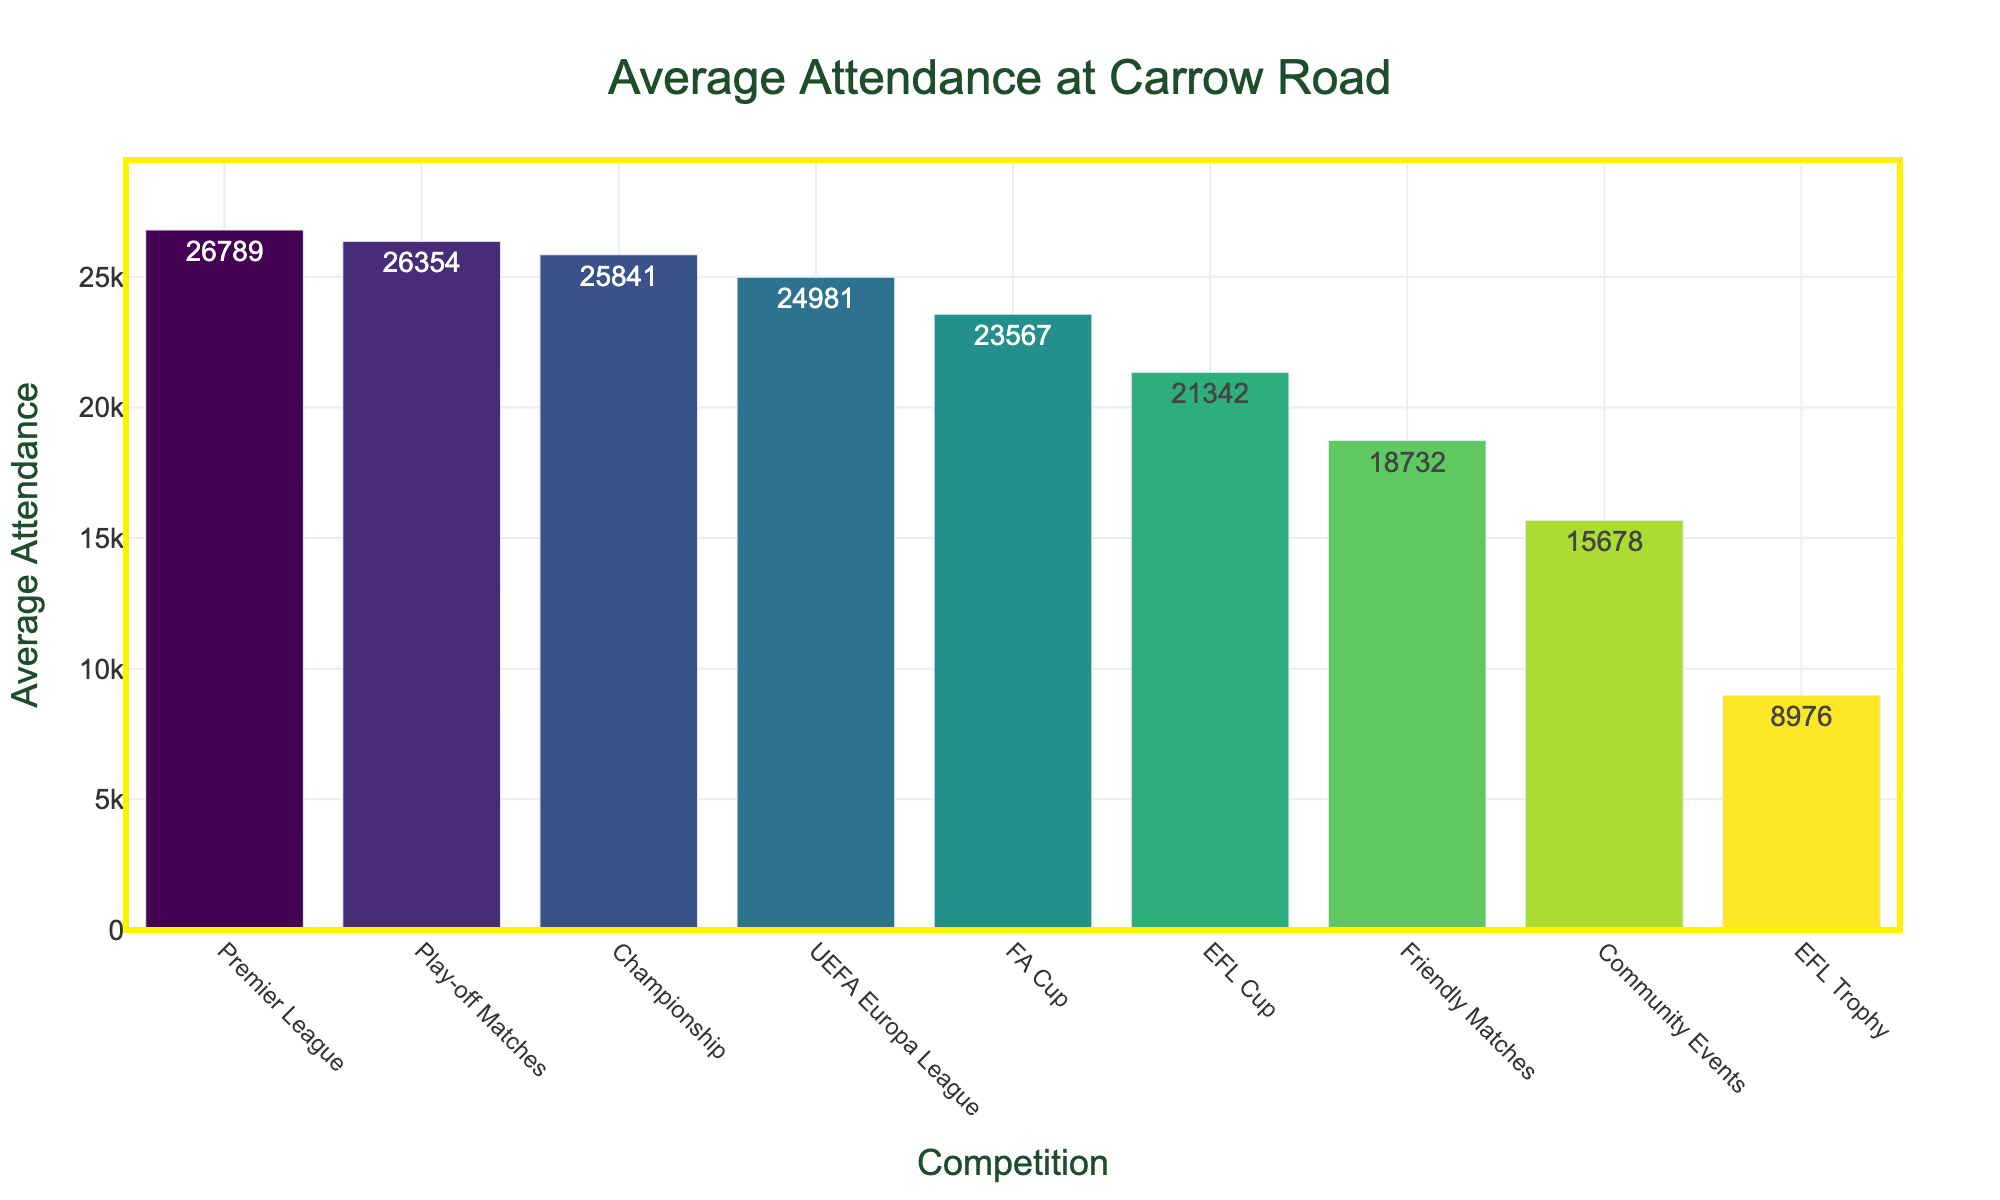Which competition has the highest average attendance? The bar chart shows that the Premier League has the tallest bar, indicating the highest average attendance.
Answer: Premier League What is the average attendance difference between Premier League and Championship matches? According to the bar chart, the Premier League has an average attendance of 26,789, and the Championship has 25,841. The difference is 26,789 - 25,841.
Answer: 948 How does the average attendance for FA Cup matches compare to Play-off Matches? The average attendance for FA Cup matches is 23,567, while for Play-off Matches, it is 26,354, as indicated by the height of the bars. The difference is 26,354 - 23,567.
Answer: 2,787 What is the combined average attendance for FA Cup and EFL Cup matches? Summing the average attendance for FA Cup (23,567) and EFL Cup (21,342) matches gives the combined average. The total is 23,567 + 21,342.
Answer: 44,909 Which competition has less average attendance, Friendly Matches or Community Events? The bar chart shows that Friendly Matches have an average attendance of 18,732 while Community Events have 15,678, comparing their bar sizes.
Answer: Community Events By how much is the average attendance for EFL Trophy matches lower than for UEFA Europa League matches? The average attendance for EFL Trophy matches is 8,976 and for UEFA Europa League matches is 24,981. The difference is 24,981 - 8,976.
Answer: 16,005 What is the color range used in the chart? The bar chart uses a color gradient ranging from blue to yellow shades.
Answer: Blue to Yellow Which competition has the least average attendance, and what is the value? The bar chart shows that EFL Trophy has the shortest bar, indicating the least average attendance.
Answer: EFL Trophy, 8,976 What is the overall range of average attendance values? The highest average attendance is for Premier League with 26,789, and the lowest is for EFL Trophy with 8,976. The range is 26,789 - 8,976.
Answer: 17,813 In which competitions does the average attendance exceed 20,000? According to the height of the bars, Premier League (26,789), Championship (25,841), FA Cup (23,567), UEFA Europa League (24,981), and Play-off Matches (26,354) all exceed 20,000 in average attendance.
Answer: Premier League, Championship, FA Cup, UEFA Europa League, Play-off Matches 